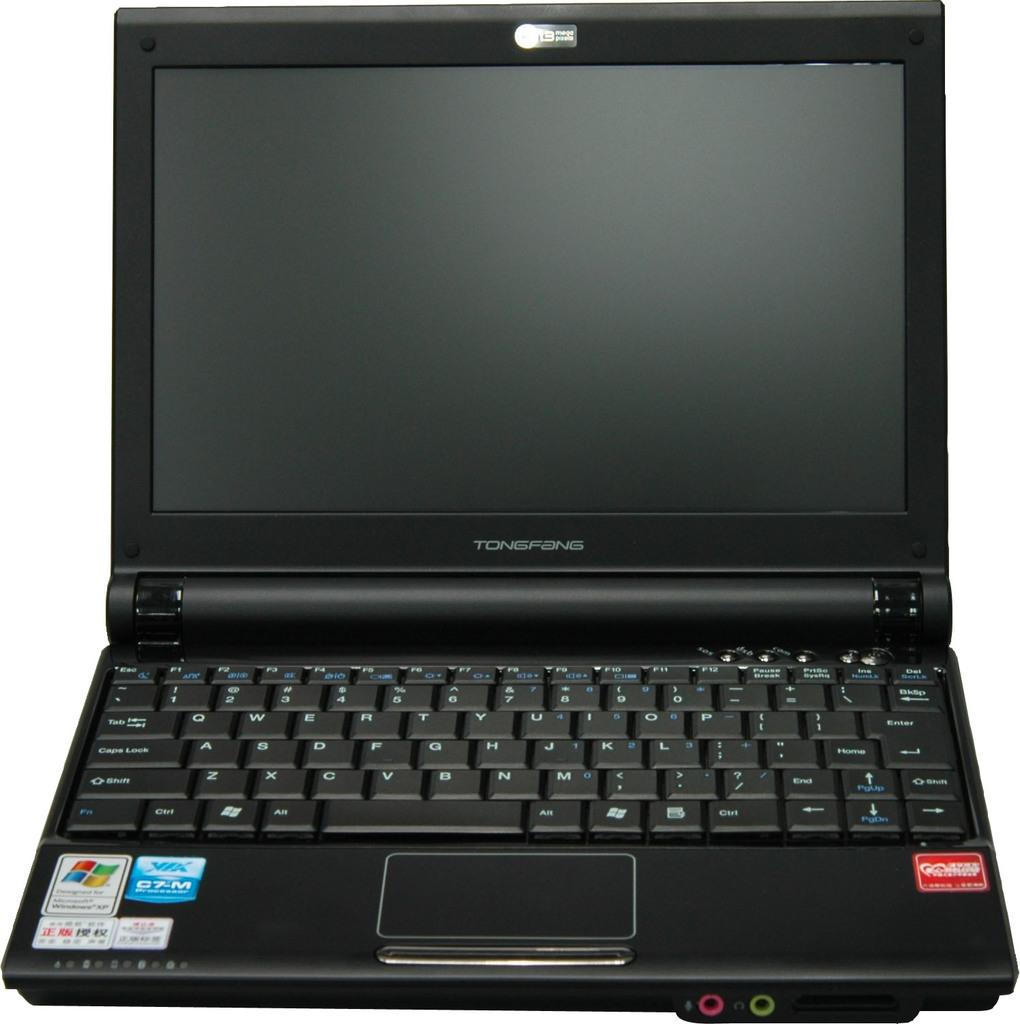Who makes this laptop?
Give a very brief answer. Tongfang. What is the brand name of this laptop?
Make the answer very short. Tongfang. 